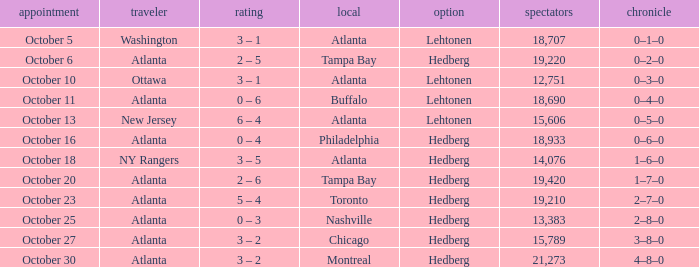What was the record on the game that was played on october 27? 3–8–0. 